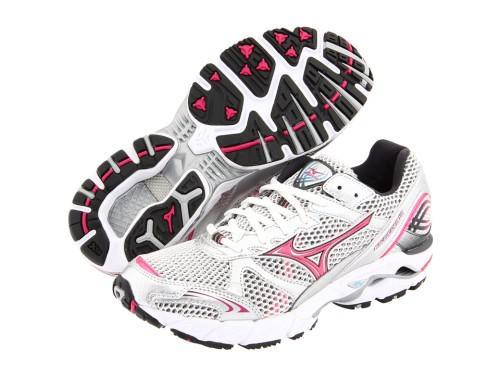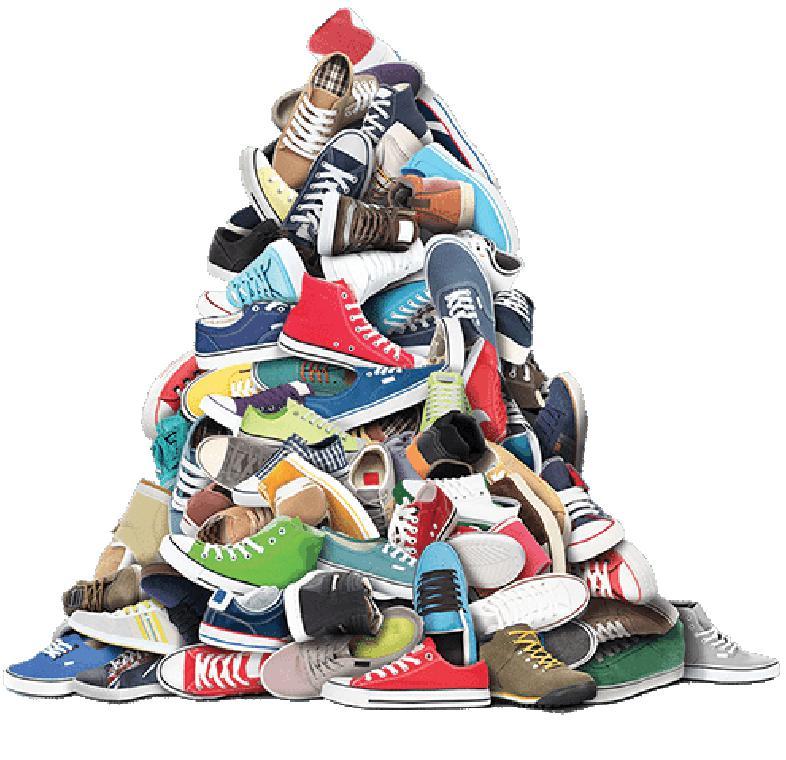The first image is the image on the left, the second image is the image on the right. Given the left and right images, does the statement "One image shows a pair of sneakers and the other shows a shoe pyramid." hold true? Answer yes or no. Yes. The first image is the image on the left, the second image is the image on the right. Evaluate the accuracy of this statement regarding the images: "Shoes are piled up together in the image on the right.". Is it true? Answer yes or no. Yes. 